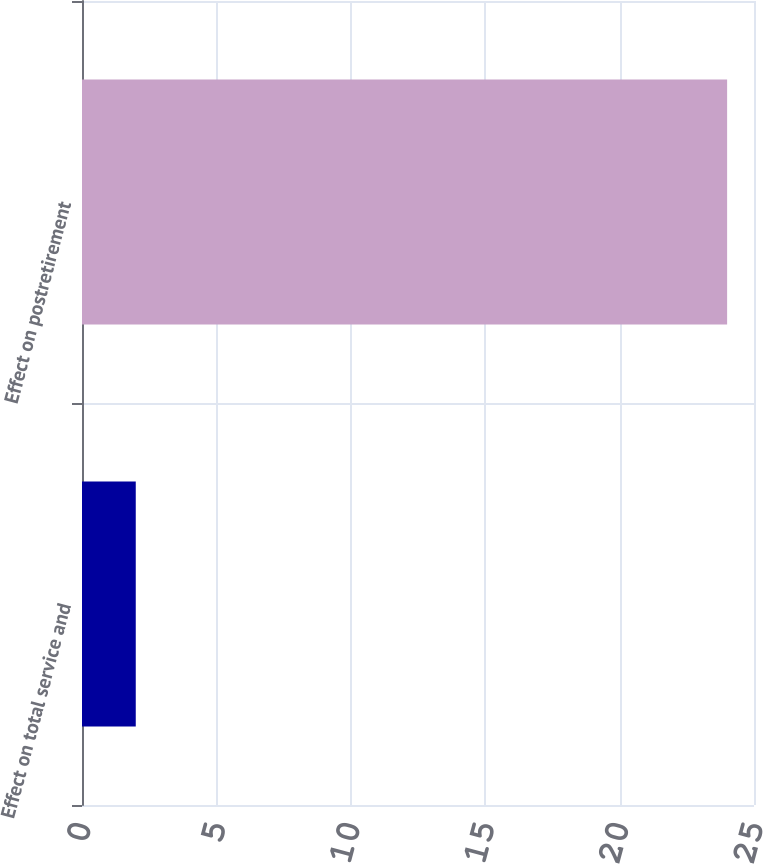<chart> <loc_0><loc_0><loc_500><loc_500><bar_chart><fcel>Effect on total service and<fcel>Effect on postretirement<nl><fcel>2<fcel>24<nl></chart> 